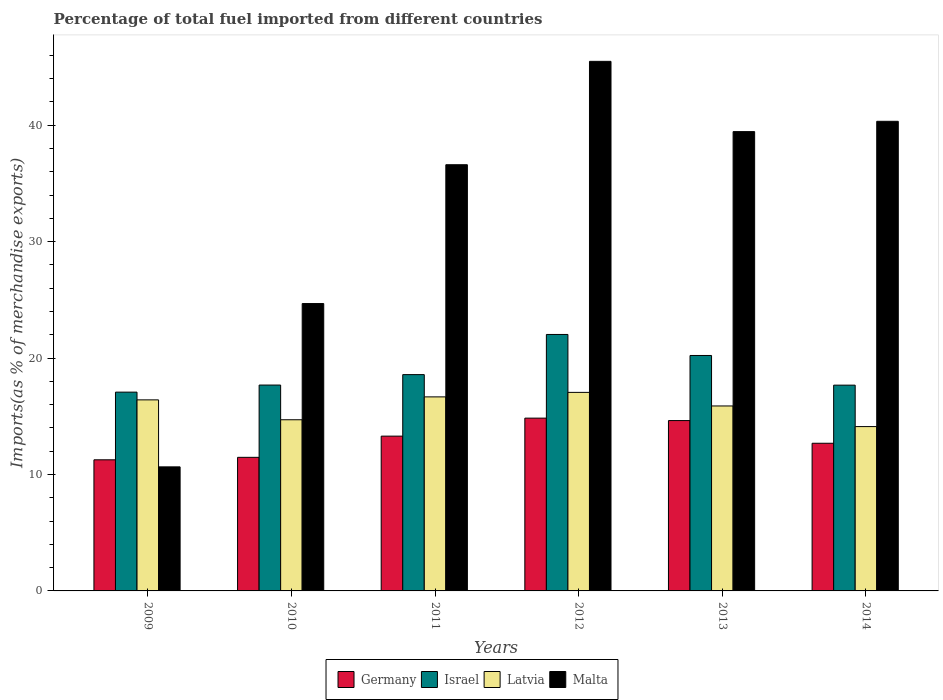How many different coloured bars are there?
Your response must be concise. 4. Are the number of bars on each tick of the X-axis equal?
Offer a very short reply. Yes. In how many cases, is the number of bars for a given year not equal to the number of legend labels?
Your answer should be compact. 0. What is the percentage of imports to different countries in Latvia in 2009?
Keep it short and to the point. 16.41. Across all years, what is the maximum percentage of imports to different countries in Latvia?
Make the answer very short. 17.05. Across all years, what is the minimum percentage of imports to different countries in Latvia?
Offer a very short reply. 14.11. In which year was the percentage of imports to different countries in Malta maximum?
Your response must be concise. 2012. In which year was the percentage of imports to different countries in Germany minimum?
Make the answer very short. 2009. What is the total percentage of imports to different countries in Israel in the graph?
Ensure brevity in your answer.  113.26. What is the difference between the percentage of imports to different countries in Latvia in 2010 and that in 2011?
Ensure brevity in your answer.  -1.96. What is the difference between the percentage of imports to different countries in Germany in 2011 and the percentage of imports to different countries in Malta in 2013?
Ensure brevity in your answer.  -26.16. What is the average percentage of imports to different countries in Germany per year?
Give a very brief answer. 13.03. In the year 2009, what is the difference between the percentage of imports to different countries in Malta and percentage of imports to different countries in Latvia?
Your response must be concise. -5.76. What is the ratio of the percentage of imports to different countries in Germany in 2009 to that in 2011?
Give a very brief answer. 0.85. Is the percentage of imports to different countries in Malta in 2010 less than that in 2011?
Ensure brevity in your answer.  Yes. Is the difference between the percentage of imports to different countries in Malta in 2013 and 2014 greater than the difference between the percentage of imports to different countries in Latvia in 2013 and 2014?
Your answer should be very brief. No. What is the difference between the highest and the second highest percentage of imports to different countries in Latvia?
Offer a terse response. 0.39. What is the difference between the highest and the lowest percentage of imports to different countries in Latvia?
Your answer should be compact. 2.94. In how many years, is the percentage of imports to different countries in Germany greater than the average percentage of imports to different countries in Germany taken over all years?
Provide a short and direct response. 3. What does the 4th bar from the left in 2010 represents?
Give a very brief answer. Malta. What does the 1st bar from the right in 2010 represents?
Provide a succinct answer. Malta. Are all the bars in the graph horizontal?
Keep it short and to the point. No. How many years are there in the graph?
Your answer should be very brief. 6. What is the difference between two consecutive major ticks on the Y-axis?
Provide a short and direct response. 10. Are the values on the major ticks of Y-axis written in scientific E-notation?
Ensure brevity in your answer.  No. Does the graph contain grids?
Your response must be concise. No. How many legend labels are there?
Provide a short and direct response. 4. How are the legend labels stacked?
Offer a terse response. Horizontal. What is the title of the graph?
Make the answer very short. Percentage of total fuel imported from different countries. What is the label or title of the X-axis?
Your answer should be compact. Years. What is the label or title of the Y-axis?
Give a very brief answer. Imports(as % of merchandise exports). What is the Imports(as % of merchandise exports) of Germany in 2009?
Give a very brief answer. 11.26. What is the Imports(as % of merchandise exports) in Israel in 2009?
Keep it short and to the point. 17.07. What is the Imports(as % of merchandise exports) of Latvia in 2009?
Offer a terse response. 16.41. What is the Imports(as % of merchandise exports) of Malta in 2009?
Keep it short and to the point. 10.66. What is the Imports(as % of merchandise exports) in Germany in 2010?
Offer a terse response. 11.47. What is the Imports(as % of merchandise exports) of Israel in 2010?
Your answer should be compact. 17.68. What is the Imports(as % of merchandise exports) of Latvia in 2010?
Ensure brevity in your answer.  14.7. What is the Imports(as % of merchandise exports) of Malta in 2010?
Make the answer very short. 24.68. What is the Imports(as % of merchandise exports) of Germany in 2011?
Provide a succinct answer. 13.3. What is the Imports(as % of merchandise exports) in Israel in 2011?
Offer a very short reply. 18.58. What is the Imports(as % of merchandise exports) of Latvia in 2011?
Offer a terse response. 16.67. What is the Imports(as % of merchandise exports) of Malta in 2011?
Offer a terse response. 36.61. What is the Imports(as % of merchandise exports) of Germany in 2012?
Provide a succinct answer. 14.84. What is the Imports(as % of merchandise exports) of Israel in 2012?
Offer a very short reply. 22.03. What is the Imports(as % of merchandise exports) in Latvia in 2012?
Keep it short and to the point. 17.05. What is the Imports(as % of merchandise exports) of Malta in 2012?
Provide a succinct answer. 45.49. What is the Imports(as % of merchandise exports) of Germany in 2013?
Offer a very short reply. 14.63. What is the Imports(as % of merchandise exports) of Israel in 2013?
Your answer should be very brief. 20.22. What is the Imports(as % of merchandise exports) in Latvia in 2013?
Offer a terse response. 15.89. What is the Imports(as % of merchandise exports) in Malta in 2013?
Ensure brevity in your answer.  39.45. What is the Imports(as % of merchandise exports) of Germany in 2014?
Your answer should be very brief. 12.68. What is the Imports(as % of merchandise exports) of Israel in 2014?
Provide a succinct answer. 17.67. What is the Imports(as % of merchandise exports) of Latvia in 2014?
Make the answer very short. 14.11. What is the Imports(as % of merchandise exports) of Malta in 2014?
Your answer should be very brief. 40.34. Across all years, what is the maximum Imports(as % of merchandise exports) of Germany?
Make the answer very short. 14.84. Across all years, what is the maximum Imports(as % of merchandise exports) in Israel?
Keep it short and to the point. 22.03. Across all years, what is the maximum Imports(as % of merchandise exports) of Latvia?
Make the answer very short. 17.05. Across all years, what is the maximum Imports(as % of merchandise exports) of Malta?
Offer a very short reply. 45.49. Across all years, what is the minimum Imports(as % of merchandise exports) of Germany?
Provide a succinct answer. 11.26. Across all years, what is the minimum Imports(as % of merchandise exports) of Israel?
Keep it short and to the point. 17.07. Across all years, what is the minimum Imports(as % of merchandise exports) of Latvia?
Give a very brief answer. 14.11. Across all years, what is the minimum Imports(as % of merchandise exports) of Malta?
Your answer should be compact. 10.66. What is the total Imports(as % of merchandise exports) in Germany in the graph?
Make the answer very short. 78.19. What is the total Imports(as % of merchandise exports) in Israel in the graph?
Provide a succinct answer. 113.26. What is the total Imports(as % of merchandise exports) of Latvia in the graph?
Ensure brevity in your answer.  94.83. What is the total Imports(as % of merchandise exports) of Malta in the graph?
Offer a terse response. 197.22. What is the difference between the Imports(as % of merchandise exports) of Germany in 2009 and that in 2010?
Make the answer very short. -0.21. What is the difference between the Imports(as % of merchandise exports) of Israel in 2009 and that in 2010?
Your answer should be compact. -0.61. What is the difference between the Imports(as % of merchandise exports) of Latvia in 2009 and that in 2010?
Offer a very short reply. 1.71. What is the difference between the Imports(as % of merchandise exports) in Malta in 2009 and that in 2010?
Keep it short and to the point. -14.03. What is the difference between the Imports(as % of merchandise exports) in Germany in 2009 and that in 2011?
Your answer should be compact. -2.03. What is the difference between the Imports(as % of merchandise exports) of Israel in 2009 and that in 2011?
Give a very brief answer. -1.5. What is the difference between the Imports(as % of merchandise exports) of Latvia in 2009 and that in 2011?
Offer a very short reply. -0.26. What is the difference between the Imports(as % of merchandise exports) in Malta in 2009 and that in 2011?
Keep it short and to the point. -25.95. What is the difference between the Imports(as % of merchandise exports) of Germany in 2009 and that in 2012?
Provide a succinct answer. -3.58. What is the difference between the Imports(as % of merchandise exports) of Israel in 2009 and that in 2012?
Your response must be concise. -4.95. What is the difference between the Imports(as % of merchandise exports) in Latvia in 2009 and that in 2012?
Your response must be concise. -0.64. What is the difference between the Imports(as % of merchandise exports) of Malta in 2009 and that in 2012?
Offer a terse response. -34.83. What is the difference between the Imports(as % of merchandise exports) in Germany in 2009 and that in 2013?
Offer a very short reply. -3.37. What is the difference between the Imports(as % of merchandise exports) in Israel in 2009 and that in 2013?
Offer a terse response. -3.15. What is the difference between the Imports(as % of merchandise exports) in Latvia in 2009 and that in 2013?
Make the answer very short. 0.52. What is the difference between the Imports(as % of merchandise exports) of Malta in 2009 and that in 2013?
Ensure brevity in your answer.  -28.8. What is the difference between the Imports(as % of merchandise exports) of Germany in 2009 and that in 2014?
Keep it short and to the point. -1.42. What is the difference between the Imports(as % of merchandise exports) in Israel in 2009 and that in 2014?
Ensure brevity in your answer.  -0.6. What is the difference between the Imports(as % of merchandise exports) in Latvia in 2009 and that in 2014?
Offer a very short reply. 2.3. What is the difference between the Imports(as % of merchandise exports) in Malta in 2009 and that in 2014?
Offer a terse response. -29.68. What is the difference between the Imports(as % of merchandise exports) in Germany in 2010 and that in 2011?
Offer a terse response. -1.82. What is the difference between the Imports(as % of merchandise exports) of Israel in 2010 and that in 2011?
Your response must be concise. -0.9. What is the difference between the Imports(as % of merchandise exports) in Latvia in 2010 and that in 2011?
Your response must be concise. -1.96. What is the difference between the Imports(as % of merchandise exports) in Malta in 2010 and that in 2011?
Your answer should be very brief. -11.92. What is the difference between the Imports(as % of merchandise exports) of Germany in 2010 and that in 2012?
Ensure brevity in your answer.  -3.37. What is the difference between the Imports(as % of merchandise exports) in Israel in 2010 and that in 2012?
Make the answer very short. -4.34. What is the difference between the Imports(as % of merchandise exports) in Latvia in 2010 and that in 2012?
Your response must be concise. -2.35. What is the difference between the Imports(as % of merchandise exports) in Malta in 2010 and that in 2012?
Offer a terse response. -20.8. What is the difference between the Imports(as % of merchandise exports) of Germany in 2010 and that in 2013?
Make the answer very short. -3.16. What is the difference between the Imports(as % of merchandise exports) of Israel in 2010 and that in 2013?
Your answer should be very brief. -2.54. What is the difference between the Imports(as % of merchandise exports) in Latvia in 2010 and that in 2013?
Your answer should be very brief. -1.18. What is the difference between the Imports(as % of merchandise exports) of Malta in 2010 and that in 2013?
Your response must be concise. -14.77. What is the difference between the Imports(as % of merchandise exports) in Germany in 2010 and that in 2014?
Your answer should be very brief. -1.21. What is the difference between the Imports(as % of merchandise exports) of Israel in 2010 and that in 2014?
Offer a terse response. 0.01. What is the difference between the Imports(as % of merchandise exports) of Latvia in 2010 and that in 2014?
Provide a succinct answer. 0.59. What is the difference between the Imports(as % of merchandise exports) in Malta in 2010 and that in 2014?
Your answer should be very brief. -15.65. What is the difference between the Imports(as % of merchandise exports) in Germany in 2011 and that in 2012?
Your response must be concise. -1.55. What is the difference between the Imports(as % of merchandise exports) of Israel in 2011 and that in 2012?
Your answer should be compact. -3.45. What is the difference between the Imports(as % of merchandise exports) in Latvia in 2011 and that in 2012?
Your response must be concise. -0.39. What is the difference between the Imports(as % of merchandise exports) in Malta in 2011 and that in 2012?
Give a very brief answer. -8.88. What is the difference between the Imports(as % of merchandise exports) of Germany in 2011 and that in 2013?
Keep it short and to the point. -1.34. What is the difference between the Imports(as % of merchandise exports) of Israel in 2011 and that in 2013?
Ensure brevity in your answer.  -1.64. What is the difference between the Imports(as % of merchandise exports) of Latvia in 2011 and that in 2013?
Keep it short and to the point. 0.78. What is the difference between the Imports(as % of merchandise exports) of Malta in 2011 and that in 2013?
Offer a terse response. -2.84. What is the difference between the Imports(as % of merchandise exports) of Germany in 2011 and that in 2014?
Provide a succinct answer. 0.61. What is the difference between the Imports(as % of merchandise exports) in Israel in 2011 and that in 2014?
Make the answer very short. 0.9. What is the difference between the Imports(as % of merchandise exports) of Latvia in 2011 and that in 2014?
Keep it short and to the point. 2.55. What is the difference between the Imports(as % of merchandise exports) of Malta in 2011 and that in 2014?
Your answer should be compact. -3.73. What is the difference between the Imports(as % of merchandise exports) of Germany in 2012 and that in 2013?
Offer a terse response. 0.21. What is the difference between the Imports(as % of merchandise exports) in Israel in 2012 and that in 2013?
Ensure brevity in your answer.  1.8. What is the difference between the Imports(as % of merchandise exports) in Latvia in 2012 and that in 2013?
Your response must be concise. 1.17. What is the difference between the Imports(as % of merchandise exports) of Malta in 2012 and that in 2013?
Provide a succinct answer. 6.03. What is the difference between the Imports(as % of merchandise exports) in Germany in 2012 and that in 2014?
Your response must be concise. 2.16. What is the difference between the Imports(as % of merchandise exports) of Israel in 2012 and that in 2014?
Your answer should be compact. 4.35. What is the difference between the Imports(as % of merchandise exports) in Latvia in 2012 and that in 2014?
Make the answer very short. 2.94. What is the difference between the Imports(as % of merchandise exports) of Malta in 2012 and that in 2014?
Provide a succinct answer. 5.15. What is the difference between the Imports(as % of merchandise exports) in Germany in 2013 and that in 2014?
Give a very brief answer. 1.95. What is the difference between the Imports(as % of merchandise exports) of Israel in 2013 and that in 2014?
Offer a very short reply. 2.55. What is the difference between the Imports(as % of merchandise exports) of Latvia in 2013 and that in 2014?
Give a very brief answer. 1.77. What is the difference between the Imports(as % of merchandise exports) in Malta in 2013 and that in 2014?
Make the answer very short. -0.88. What is the difference between the Imports(as % of merchandise exports) of Germany in 2009 and the Imports(as % of merchandise exports) of Israel in 2010?
Your answer should be compact. -6.42. What is the difference between the Imports(as % of merchandise exports) of Germany in 2009 and the Imports(as % of merchandise exports) of Latvia in 2010?
Provide a succinct answer. -3.44. What is the difference between the Imports(as % of merchandise exports) in Germany in 2009 and the Imports(as % of merchandise exports) in Malta in 2010?
Keep it short and to the point. -13.42. What is the difference between the Imports(as % of merchandise exports) of Israel in 2009 and the Imports(as % of merchandise exports) of Latvia in 2010?
Your answer should be very brief. 2.37. What is the difference between the Imports(as % of merchandise exports) of Israel in 2009 and the Imports(as % of merchandise exports) of Malta in 2010?
Ensure brevity in your answer.  -7.61. What is the difference between the Imports(as % of merchandise exports) of Latvia in 2009 and the Imports(as % of merchandise exports) of Malta in 2010?
Offer a very short reply. -8.27. What is the difference between the Imports(as % of merchandise exports) in Germany in 2009 and the Imports(as % of merchandise exports) in Israel in 2011?
Your response must be concise. -7.32. What is the difference between the Imports(as % of merchandise exports) in Germany in 2009 and the Imports(as % of merchandise exports) in Latvia in 2011?
Your answer should be very brief. -5.4. What is the difference between the Imports(as % of merchandise exports) of Germany in 2009 and the Imports(as % of merchandise exports) of Malta in 2011?
Make the answer very short. -25.34. What is the difference between the Imports(as % of merchandise exports) in Israel in 2009 and the Imports(as % of merchandise exports) in Latvia in 2011?
Provide a succinct answer. 0.41. What is the difference between the Imports(as % of merchandise exports) in Israel in 2009 and the Imports(as % of merchandise exports) in Malta in 2011?
Offer a terse response. -19.53. What is the difference between the Imports(as % of merchandise exports) of Latvia in 2009 and the Imports(as % of merchandise exports) of Malta in 2011?
Make the answer very short. -20.2. What is the difference between the Imports(as % of merchandise exports) in Germany in 2009 and the Imports(as % of merchandise exports) in Israel in 2012?
Provide a short and direct response. -10.77. What is the difference between the Imports(as % of merchandise exports) of Germany in 2009 and the Imports(as % of merchandise exports) of Latvia in 2012?
Give a very brief answer. -5.79. What is the difference between the Imports(as % of merchandise exports) in Germany in 2009 and the Imports(as % of merchandise exports) in Malta in 2012?
Your answer should be very brief. -34.22. What is the difference between the Imports(as % of merchandise exports) of Israel in 2009 and the Imports(as % of merchandise exports) of Latvia in 2012?
Give a very brief answer. 0.02. What is the difference between the Imports(as % of merchandise exports) in Israel in 2009 and the Imports(as % of merchandise exports) in Malta in 2012?
Offer a very short reply. -28.41. What is the difference between the Imports(as % of merchandise exports) in Latvia in 2009 and the Imports(as % of merchandise exports) in Malta in 2012?
Offer a terse response. -29.08. What is the difference between the Imports(as % of merchandise exports) of Germany in 2009 and the Imports(as % of merchandise exports) of Israel in 2013?
Make the answer very short. -8.96. What is the difference between the Imports(as % of merchandise exports) of Germany in 2009 and the Imports(as % of merchandise exports) of Latvia in 2013?
Offer a terse response. -4.62. What is the difference between the Imports(as % of merchandise exports) in Germany in 2009 and the Imports(as % of merchandise exports) in Malta in 2013?
Offer a terse response. -28.19. What is the difference between the Imports(as % of merchandise exports) of Israel in 2009 and the Imports(as % of merchandise exports) of Latvia in 2013?
Give a very brief answer. 1.19. What is the difference between the Imports(as % of merchandise exports) of Israel in 2009 and the Imports(as % of merchandise exports) of Malta in 2013?
Your response must be concise. -22.38. What is the difference between the Imports(as % of merchandise exports) in Latvia in 2009 and the Imports(as % of merchandise exports) in Malta in 2013?
Your answer should be very brief. -23.04. What is the difference between the Imports(as % of merchandise exports) in Germany in 2009 and the Imports(as % of merchandise exports) in Israel in 2014?
Make the answer very short. -6.41. What is the difference between the Imports(as % of merchandise exports) in Germany in 2009 and the Imports(as % of merchandise exports) in Latvia in 2014?
Ensure brevity in your answer.  -2.85. What is the difference between the Imports(as % of merchandise exports) of Germany in 2009 and the Imports(as % of merchandise exports) of Malta in 2014?
Provide a succinct answer. -29.07. What is the difference between the Imports(as % of merchandise exports) of Israel in 2009 and the Imports(as % of merchandise exports) of Latvia in 2014?
Provide a short and direct response. 2.96. What is the difference between the Imports(as % of merchandise exports) of Israel in 2009 and the Imports(as % of merchandise exports) of Malta in 2014?
Provide a short and direct response. -23.26. What is the difference between the Imports(as % of merchandise exports) of Latvia in 2009 and the Imports(as % of merchandise exports) of Malta in 2014?
Your response must be concise. -23.93. What is the difference between the Imports(as % of merchandise exports) of Germany in 2010 and the Imports(as % of merchandise exports) of Israel in 2011?
Provide a short and direct response. -7.11. What is the difference between the Imports(as % of merchandise exports) of Germany in 2010 and the Imports(as % of merchandise exports) of Latvia in 2011?
Offer a very short reply. -5.19. What is the difference between the Imports(as % of merchandise exports) in Germany in 2010 and the Imports(as % of merchandise exports) in Malta in 2011?
Give a very brief answer. -25.13. What is the difference between the Imports(as % of merchandise exports) in Israel in 2010 and the Imports(as % of merchandise exports) in Latvia in 2011?
Ensure brevity in your answer.  1.02. What is the difference between the Imports(as % of merchandise exports) of Israel in 2010 and the Imports(as % of merchandise exports) of Malta in 2011?
Your answer should be very brief. -18.92. What is the difference between the Imports(as % of merchandise exports) of Latvia in 2010 and the Imports(as % of merchandise exports) of Malta in 2011?
Provide a succinct answer. -21.91. What is the difference between the Imports(as % of merchandise exports) of Germany in 2010 and the Imports(as % of merchandise exports) of Israel in 2012?
Ensure brevity in your answer.  -10.55. What is the difference between the Imports(as % of merchandise exports) in Germany in 2010 and the Imports(as % of merchandise exports) in Latvia in 2012?
Keep it short and to the point. -5.58. What is the difference between the Imports(as % of merchandise exports) in Germany in 2010 and the Imports(as % of merchandise exports) in Malta in 2012?
Offer a very short reply. -34.01. What is the difference between the Imports(as % of merchandise exports) of Israel in 2010 and the Imports(as % of merchandise exports) of Latvia in 2012?
Keep it short and to the point. 0.63. What is the difference between the Imports(as % of merchandise exports) in Israel in 2010 and the Imports(as % of merchandise exports) in Malta in 2012?
Provide a short and direct response. -27.8. What is the difference between the Imports(as % of merchandise exports) in Latvia in 2010 and the Imports(as % of merchandise exports) in Malta in 2012?
Provide a short and direct response. -30.78. What is the difference between the Imports(as % of merchandise exports) of Germany in 2010 and the Imports(as % of merchandise exports) of Israel in 2013?
Provide a succinct answer. -8.75. What is the difference between the Imports(as % of merchandise exports) of Germany in 2010 and the Imports(as % of merchandise exports) of Latvia in 2013?
Your answer should be very brief. -4.41. What is the difference between the Imports(as % of merchandise exports) of Germany in 2010 and the Imports(as % of merchandise exports) of Malta in 2013?
Provide a succinct answer. -27.98. What is the difference between the Imports(as % of merchandise exports) of Israel in 2010 and the Imports(as % of merchandise exports) of Latvia in 2013?
Your answer should be compact. 1.8. What is the difference between the Imports(as % of merchandise exports) in Israel in 2010 and the Imports(as % of merchandise exports) in Malta in 2013?
Give a very brief answer. -21.77. What is the difference between the Imports(as % of merchandise exports) of Latvia in 2010 and the Imports(as % of merchandise exports) of Malta in 2013?
Provide a short and direct response. -24.75. What is the difference between the Imports(as % of merchandise exports) of Germany in 2010 and the Imports(as % of merchandise exports) of Israel in 2014?
Make the answer very short. -6.2. What is the difference between the Imports(as % of merchandise exports) in Germany in 2010 and the Imports(as % of merchandise exports) in Latvia in 2014?
Provide a succinct answer. -2.64. What is the difference between the Imports(as % of merchandise exports) in Germany in 2010 and the Imports(as % of merchandise exports) in Malta in 2014?
Your answer should be very brief. -28.86. What is the difference between the Imports(as % of merchandise exports) of Israel in 2010 and the Imports(as % of merchandise exports) of Latvia in 2014?
Make the answer very short. 3.57. What is the difference between the Imports(as % of merchandise exports) in Israel in 2010 and the Imports(as % of merchandise exports) in Malta in 2014?
Your response must be concise. -22.65. What is the difference between the Imports(as % of merchandise exports) of Latvia in 2010 and the Imports(as % of merchandise exports) of Malta in 2014?
Keep it short and to the point. -25.63. What is the difference between the Imports(as % of merchandise exports) in Germany in 2011 and the Imports(as % of merchandise exports) in Israel in 2012?
Ensure brevity in your answer.  -8.73. What is the difference between the Imports(as % of merchandise exports) of Germany in 2011 and the Imports(as % of merchandise exports) of Latvia in 2012?
Offer a terse response. -3.76. What is the difference between the Imports(as % of merchandise exports) of Germany in 2011 and the Imports(as % of merchandise exports) of Malta in 2012?
Provide a succinct answer. -32.19. What is the difference between the Imports(as % of merchandise exports) of Israel in 2011 and the Imports(as % of merchandise exports) of Latvia in 2012?
Provide a short and direct response. 1.53. What is the difference between the Imports(as % of merchandise exports) of Israel in 2011 and the Imports(as % of merchandise exports) of Malta in 2012?
Ensure brevity in your answer.  -26.91. What is the difference between the Imports(as % of merchandise exports) of Latvia in 2011 and the Imports(as % of merchandise exports) of Malta in 2012?
Keep it short and to the point. -28.82. What is the difference between the Imports(as % of merchandise exports) of Germany in 2011 and the Imports(as % of merchandise exports) of Israel in 2013?
Provide a succinct answer. -6.93. What is the difference between the Imports(as % of merchandise exports) of Germany in 2011 and the Imports(as % of merchandise exports) of Latvia in 2013?
Ensure brevity in your answer.  -2.59. What is the difference between the Imports(as % of merchandise exports) in Germany in 2011 and the Imports(as % of merchandise exports) in Malta in 2013?
Your response must be concise. -26.16. What is the difference between the Imports(as % of merchandise exports) of Israel in 2011 and the Imports(as % of merchandise exports) of Latvia in 2013?
Offer a very short reply. 2.69. What is the difference between the Imports(as % of merchandise exports) in Israel in 2011 and the Imports(as % of merchandise exports) in Malta in 2013?
Provide a succinct answer. -20.87. What is the difference between the Imports(as % of merchandise exports) of Latvia in 2011 and the Imports(as % of merchandise exports) of Malta in 2013?
Your response must be concise. -22.78. What is the difference between the Imports(as % of merchandise exports) of Germany in 2011 and the Imports(as % of merchandise exports) of Israel in 2014?
Make the answer very short. -4.38. What is the difference between the Imports(as % of merchandise exports) of Germany in 2011 and the Imports(as % of merchandise exports) of Latvia in 2014?
Offer a terse response. -0.82. What is the difference between the Imports(as % of merchandise exports) of Germany in 2011 and the Imports(as % of merchandise exports) of Malta in 2014?
Your response must be concise. -27.04. What is the difference between the Imports(as % of merchandise exports) of Israel in 2011 and the Imports(as % of merchandise exports) of Latvia in 2014?
Offer a very short reply. 4.46. What is the difference between the Imports(as % of merchandise exports) in Israel in 2011 and the Imports(as % of merchandise exports) in Malta in 2014?
Your response must be concise. -21.76. What is the difference between the Imports(as % of merchandise exports) in Latvia in 2011 and the Imports(as % of merchandise exports) in Malta in 2014?
Make the answer very short. -23.67. What is the difference between the Imports(as % of merchandise exports) in Germany in 2012 and the Imports(as % of merchandise exports) in Israel in 2013?
Ensure brevity in your answer.  -5.38. What is the difference between the Imports(as % of merchandise exports) in Germany in 2012 and the Imports(as % of merchandise exports) in Latvia in 2013?
Offer a terse response. -1.05. What is the difference between the Imports(as % of merchandise exports) of Germany in 2012 and the Imports(as % of merchandise exports) of Malta in 2013?
Your response must be concise. -24.61. What is the difference between the Imports(as % of merchandise exports) in Israel in 2012 and the Imports(as % of merchandise exports) in Latvia in 2013?
Offer a terse response. 6.14. What is the difference between the Imports(as % of merchandise exports) in Israel in 2012 and the Imports(as % of merchandise exports) in Malta in 2013?
Your answer should be very brief. -17.42. What is the difference between the Imports(as % of merchandise exports) of Latvia in 2012 and the Imports(as % of merchandise exports) of Malta in 2013?
Your response must be concise. -22.4. What is the difference between the Imports(as % of merchandise exports) in Germany in 2012 and the Imports(as % of merchandise exports) in Israel in 2014?
Provide a succinct answer. -2.83. What is the difference between the Imports(as % of merchandise exports) of Germany in 2012 and the Imports(as % of merchandise exports) of Latvia in 2014?
Provide a short and direct response. 0.73. What is the difference between the Imports(as % of merchandise exports) in Germany in 2012 and the Imports(as % of merchandise exports) in Malta in 2014?
Offer a very short reply. -25.49. What is the difference between the Imports(as % of merchandise exports) in Israel in 2012 and the Imports(as % of merchandise exports) in Latvia in 2014?
Your answer should be very brief. 7.91. What is the difference between the Imports(as % of merchandise exports) of Israel in 2012 and the Imports(as % of merchandise exports) of Malta in 2014?
Give a very brief answer. -18.31. What is the difference between the Imports(as % of merchandise exports) in Latvia in 2012 and the Imports(as % of merchandise exports) in Malta in 2014?
Your answer should be very brief. -23.28. What is the difference between the Imports(as % of merchandise exports) of Germany in 2013 and the Imports(as % of merchandise exports) of Israel in 2014?
Your response must be concise. -3.04. What is the difference between the Imports(as % of merchandise exports) of Germany in 2013 and the Imports(as % of merchandise exports) of Latvia in 2014?
Ensure brevity in your answer.  0.52. What is the difference between the Imports(as % of merchandise exports) in Germany in 2013 and the Imports(as % of merchandise exports) in Malta in 2014?
Provide a short and direct response. -25.7. What is the difference between the Imports(as % of merchandise exports) in Israel in 2013 and the Imports(as % of merchandise exports) in Latvia in 2014?
Your response must be concise. 6.11. What is the difference between the Imports(as % of merchandise exports) in Israel in 2013 and the Imports(as % of merchandise exports) in Malta in 2014?
Your answer should be very brief. -20.11. What is the difference between the Imports(as % of merchandise exports) of Latvia in 2013 and the Imports(as % of merchandise exports) of Malta in 2014?
Keep it short and to the point. -24.45. What is the average Imports(as % of merchandise exports) of Germany per year?
Ensure brevity in your answer.  13.03. What is the average Imports(as % of merchandise exports) in Israel per year?
Offer a very short reply. 18.88. What is the average Imports(as % of merchandise exports) in Latvia per year?
Keep it short and to the point. 15.81. What is the average Imports(as % of merchandise exports) of Malta per year?
Offer a very short reply. 32.87. In the year 2009, what is the difference between the Imports(as % of merchandise exports) in Germany and Imports(as % of merchandise exports) in Israel?
Give a very brief answer. -5.81. In the year 2009, what is the difference between the Imports(as % of merchandise exports) in Germany and Imports(as % of merchandise exports) in Latvia?
Keep it short and to the point. -5.15. In the year 2009, what is the difference between the Imports(as % of merchandise exports) in Germany and Imports(as % of merchandise exports) in Malta?
Your response must be concise. 0.61. In the year 2009, what is the difference between the Imports(as % of merchandise exports) in Israel and Imports(as % of merchandise exports) in Latvia?
Give a very brief answer. 0.66. In the year 2009, what is the difference between the Imports(as % of merchandise exports) in Israel and Imports(as % of merchandise exports) in Malta?
Provide a succinct answer. 6.42. In the year 2009, what is the difference between the Imports(as % of merchandise exports) in Latvia and Imports(as % of merchandise exports) in Malta?
Your answer should be very brief. 5.76. In the year 2010, what is the difference between the Imports(as % of merchandise exports) of Germany and Imports(as % of merchandise exports) of Israel?
Provide a succinct answer. -6.21. In the year 2010, what is the difference between the Imports(as % of merchandise exports) in Germany and Imports(as % of merchandise exports) in Latvia?
Your response must be concise. -3.23. In the year 2010, what is the difference between the Imports(as % of merchandise exports) in Germany and Imports(as % of merchandise exports) in Malta?
Your answer should be very brief. -13.21. In the year 2010, what is the difference between the Imports(as % of merchandise exports) of Israel and Imports(as % of merchandise exports) of Latvia?
Provide a short and direct response. 2.98. In the year 2010, what is the difference between the Imports(as % of merchandise exports) in Israel and Imports(as % of merchandise exports) in Malta?
Give a very brief answer. -7. In the year 2010, what is the difference between the Imports(as % of merchandise exports) of Latvia and Imports(as % of merchandise exports) of Malta?
Offer a very short reply. -9.98. In the year 2011, what is the difference between the Imports(as % of merchandise exports) in Germany and Imports(as % of merchandise exports) in Israel?
Make the answer very short. -5.28. In the year 2011, what is the difference between the Imports(as % of merchandise exports) of Germany and Imports(as % of merchandise exports) of Latvia?
Your response must be concise. -3.37. In the year 2011, what is the difference between the Imports(as % of merchandise exports) in Germany and Imports(as % of merchandise exports) in Malta?
Make the answer very short. -23.31. In the year 2011, what is the difference between the Imports(as % of merchandise exports) of Israel and Imports(as % of merchandise exports) of Latvia?
Offer a terse response. 1.91. In the year 2011, what is the difference between the Imports(as % of merchandise exports) in Israel and Imports(as % of merchandise exports) in Malta?
Offer a very short reply. -18.03. In the year 2011, what is the difference between the Imports(as % of merchandise exports) in Latvia and Imports(as % of merchandise exports) in Malta?
Your response must be concise. -19.94. In the year 2012, what is the difference between the Imports(as % of merchandise exports) in Germany and Imports(as % of merchandise exports) in Israel?
Ensure brevity in your answer.  -7.19. In the year 2012, what is the difference between the Imports(as % of merchandise exports) of Germany and Imports(as % of merchandise exports) of Latvia?
Keep it short and to the point. -2.21. In the year 2012, what is the difference between the Imports(as % of merchandise exports) in Germany and Imports(as % of merchandise exports) in Malta?
Offer a terse response. -30.64. In the year 2012, what is the difference between the Imports(as % of merchandise exports) of Israel and Imports(as % of merchandise exports) of Latvia?
Make the answer very short. 4.97. In the year 2012, what is the difference between the Imports(as % of merchandise exports) in Israel and Imports(as % of merchandise exports) in Malta?
Provide a short and direct response. -23.46. In the year 2012, what is the difference between the Imports(as % of merchandise exports) in Latvia and Imports(as % of merchandise exports) in Malta?
Your response must be concise. -28.43. In the year 2013, what is the difference between the Imports(as % of merchandise exports) in Germany and Imports(as % of merchandise exports) in Israel?
Offer a very short reply. -5.59. In the year 2013, what is the difference between the Imports(as % of merchandise exports) in Germany and Imports(as % of merchandise exports) in Latvia?
Give a very brief answer. -1.25. In the year 2013, what is the difference between the Imports(as % of merchandise exports) in Germany and Imports(as % of merchandise exports) in Malta?
Offer a terse response. -24.82. In the year 2013, what is the difference between the Imports(as % of merchandise exports) in Israel and Imports(as % of merchandise exports) in Latvia?
Your answer should be compact. 4.34. In the year 2013, what is the difference between the Imports(as % of merchandise exports) in Israel and Imports(as % of merchandise exports) in Malta?
Offer a terse response. -19.23. In the year 2013, what is the difference between the Imports(as % of merchandise exports) in Latvia and Imports(as % of merchandise exports) in Malta?
Ensure brevity in your answer.  -23.56. In the year 2014, what is the difference between the Imports(as % of merchandise exports) in Germany and Imports(as % of merchandise exports) in Israel?
Provide a short and direct response. -4.99. In the year 2014, what is the difference between the Imports(as % of merchandise exports) of Germany and Imports(as % of merchandise exports) of Latvia?
Offer a very short reply. -1.43. In the year 2014, what is the difference between the Imports(as % of merchandise exports) of Germany and Imports(as % of merchandise exports) of Malta?
Your response must be concise. -27.65. In the year 2014, what is the difference between the Imports(as % of merchandise exports) of Israel and Imports(as % of merchandise exports) of Latvia?
Offer a terse response. 3.56. In the year 2014, what is the difference between the Imports(as % of merchandise exports) in Israel and Imports(as % of merchandise exports) in Malta?
Your response must be concise. -22.66. In the year 2014, what is the difference between the Imports(as % of merchandise exports) of Latvia and Imports(as % of merchandise exports) of Malta?
Provide a short and direct response. -26.22. What is the ratio of the Imports(as % of merchandise exports) in Germany in 2009 to that in 2010?
Provide a short and direct response. 0.98. What is the ratio of the Imports(as % of merchandise exports) of Israel in 2009 to that in 2010?
Your answer should be very brief. 0.97. What is the ratio of the Imports(as % of merchandise exports) in Latvia in 2009 to that in 2010?
Keep it short and to the point. 1.12. What is the ratio of the Imports(as % of merchandise exports) in Malta in 2009 to that in 2010?
Your answer should be compact. 0.43. What is the ratio of the Imports(as % of merchandise exports) in Germany in 2009 to that in 2011?
Offer a terse response. 0.85. What is the ratio of the Imports(as % of merchandise exports) of Israel in 2009 to that in 2011?
Ensure brevity in your answer.  0.92. What is the ratio of the Imports(as % of merchandise exports) of Latvia in 2009 to that in 2011?
Provide a short and direct response. 0.98. What is the ratio of the Imports(as % of merchandise exports) in Malta in 2009 to that in 2011?
Give a very brief answer. 0.29. What is the ratio of the Imports(as % of merchandise exports) of Germany in 2009 to that in 2012?
Keep it short and to the point. 0.76. What is the ratio of the Imports(as % of merchandise exports) in Israel in 2009 to that in 2012?
Provide a short and direct response. 0.78. What is the ratio of the Imports(as % of merchandise exports) of Latvia in 2009 to that in 2012?
Your response must be concise. 0.96. What is the ratio of the Imports(as % of merchandise exports) of Malta in 2009 to that in 2012?
Provide a succinct answer. 0.23. What is the ratio of the Imports(as % of merchandise exports) of Germany in 2009 to that in 2013?
Ensure brevity in your answer.  0.77. What is the ratio of the Imports(as % of merchandise exports) in Israel in 2009 to that in 2013?
Ensure brevity in your answer.  0.84. What is the ratio of the Imports(as % of merchandise exports) in Latvia in 2009 to that in 2013?
Offer a very short reply. 1.03. What is the ratio of the Imports(as % of merchandise exports) of Malta in 2009 to that in 2013?
Keep it short and to the point. 0.27. What is the ratio of the Imports(as % of merchandise exports) in Germany in 2009 to that in 2014?
Offer a very short reply. 0.89. What is the ratio of the Imports(as % of merchandise exports) of Israel in 2009 to that in 2014?
Provide a short and direct response. 0.97. What is the ratio of the Imports(as % of merchandise exports) of Latvia in 2009 to that in 2014?
Ensure brevity in your answer.  1.16. What is the ratio of the Imports(as % of merchandise exports) of Malta in 2009 to that in 2014?
Provide a short and direct response. 0.26. What is the ratio of the Imports(as % of merchandise exports) of Germany in 2010 to that in 2011?
Your answer should be very brief. 0.86. What is the ratio of the Imports(as % of merchandise exports) in Israel in 2010 to that in 2011?
Give a very brief answer. 0.95. What is the ratio of the Imports(as % of merchandise exports) of Latvia in 2010 to that in 2011?
Offer a very short reply. 0.88. What is the ratio of the Imports(as % of merchandise exports) of Malta in 2010 to that in 2011?
Offer a very short reply. 0.67. What is the ratio of the Imports(as % of merchandise exports) of Germany in 2010 to that in 2012?
Provide a short and direct response. 0.77. What is the ratio of the Imports(as % of merchandise exports) of Israel in 2010 to that in 2012?
Your response must be concise. 0.8. What is the ratio of the Imports(as % of merchandise exports) of Latvia in 2010 to that in 2012?
Ensure brevity in your answer.  0.86. What is the ratio of the Imports(as % of merchandise exports) of Malta in 2010 to that in 2012?
Offer a terse response. 0.54. What is the ratio of the Imports(as % of merchandise exports) in Germany in 2010 to that in 2013?
Provide a short and direct response. 0.78. What is the ratio of the Imports(as % of merchandise exports) in Israel in 2010 to that in 2013?
Offer a very short reply. 0.87. What is the ratio of the Imports(as % of merchandise exports) of Latvia in 2010 to that in 2013?
Provide a short and direct response. 0.93. What is the ratio of the Imports(as % of merchandise exports) of Malta in 2010 to that in 2013?
Your answer should be very brief. 0.63. What is the ratio of the Imports(as % of merchandise exports) of Germany in 2010 to that in 2014?
Give a very brief answer. 0.9. What is the ratio of the Imports(as % of merchandise exports) in Latvia in 2010 to that in 2014?
Offer a terse response. 1.04. What is the ratio of the Imports(as % of merchandise exports) of Malta in 2010 to that in 2014?
Give a very brief answer. 0.61. What is the ratio of the Imports(as % of merchandise exports) of Germany in 2011 to that in 2012?
Provide a short and direct response. 0.9. What is the ratio of the Imports(as % of merchandise exports) of Israel in 2011 to that in 2012?
Provide a short and direct response. 0.84. What is the ratio of the Imports(as % of merchandise exports) in Latvia in 2011 to that in 2012?
Provide a short and direct response. 0.98. What is the ratio of the Imports(as % of merchandise exports) in Malta in 2011 to that in 2012?
Provide a succinct answer. 0.8. What is the ratio of the Imports(as % of merchandise exports) in Germany in 2011 to that in 2013?
Your answer should be very brief. 0.91. What is the ratio of the Imports(as % of merchandise exports) of Israel in 2011 to that in 2013?
Give a very brief answer. 0.92. What is the ratio of the Imports(as % of merchandise exports) of Latvia in 2011 to that in 2013?
Offer a very short reply. 1.05. What is the ratio of the Imports(as % of merchandise exports) of Malta in 2011 to that in 2013?
Give a very brief answer. 0.93. What is the ratio of the Imports(as % of merchandise exports) of Germany in 2011 to that in 2014?
Your answer should be very brief. 1.05. What is the ratio of the Imports(as % of merchandise exports) of Israel in 2011 to that in 2014?
Make the answer very short. 1.05. What is the ratio of the Imports(as % of merchandise exports) of Latvia in 2011 to that in 2014?
Provide a short and direct response. 1.18. What is the ratio of the Imports(as % of merchandise exports) of Malta in 2011 to that in 2014?
Your answer should be very brief. 0.91. What is the ratio of the Imports(as % of merchandise exports) of Germany in 2012 to that in 2013?
Keep it short and to the point. 1.01. What is the ratio of the Imports(as % of merchandise exports) of Israel in 2012 to that in 2013?
Your answer should be compact. 1.09. What is the ratio of the Imports(as % of merchandise exports) of Latvia in 2012 to that in 2013?
Your response must be concise. 1.07. What is the ratio of the Imports(as % of merchandise exports) in Malta in 2012 to that in 2013?
Ensure brevity in your answer.  1.15. What is the ratio of the Imports(as % of merchandise exports) in Germany in 2012 to that in 2014?
Provide a succinct answer. 1.17. What is the ratio of the Imports(as % of merchandise exports) in Israel in 2012 to that in 2014?
Ensure brevity in your answer.  1.25. What is the ratio of the Imports(as % of merchandise exports) of Latvia in 2012 to that in 2014?
Your answer should be compact. 1.21. What is the ratio of the Imports(as % of merchandise exports) in Malta in 2012 to that in 2014?
Keep it short and to the point. 1.13. What is the ratio of the Imports(as % of merchandise exports) of Germany in 2013 to that in 2014?
Your response must be concise. 1.15. What is the ratio of the Imports(as % of merchandise exports) of Israel in 2013 to that in 2014?
Your answer should be compact. 1.14. What is the ratio of the Imports(as % of merchandise exports) of Latvia in 2013 to that in 2014?
Make the answer very short. 1.13. What is the ratio of the Imports(as % of merchandise exports) in Malta in 2013 to that in 2014?
Your answer should be compact. 0.98. What is the difference between the highest and the second highest Imports(as % of merchandise exports) in Germany?
Give a very brief answer. 0.21. What is the difference between the highest and the second highest Imports(as % of merchandise exports) in Israel?
Give a very brief answer. 1.8. What is the difference between the highest and the second highest Imports(as % of merchandise exports) in Latvia?
Ensure brevity in your answer.  0.39. What is the difference between the highest and the second highest Imports(as % of merchandise exports) of Malta?
Give a very brief answer. 5.15. What is the difference between the highest and the lowest Imports(as % of merchandise exports) of Germany?
Your answer should be very brief. 3.58. What is the difference between the highest and the lowest Imports(as % of merchandise exports) in Israel?
Make the answer very short. 4.95. What is the difference between the highest and the lowest Imports(as % of merchandise exports) in Latvia?
Make the answer very short. 2.94. What is the difference between the highest and the lowest Imports(as % of merchandise exports) in Malta?
Your answer should be very brief. 34.83. 